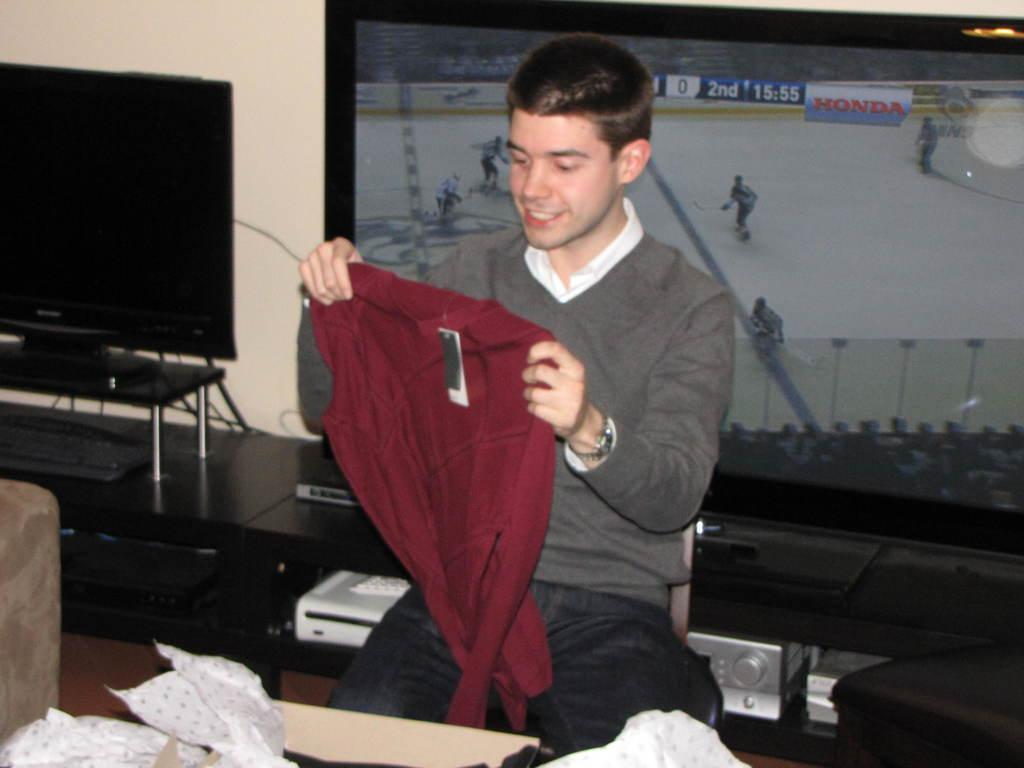<image>
Write a terse but informative summary of the picture. A man holding up a new sweater with a tv in the background showing the 2nd period of a hockey game. 